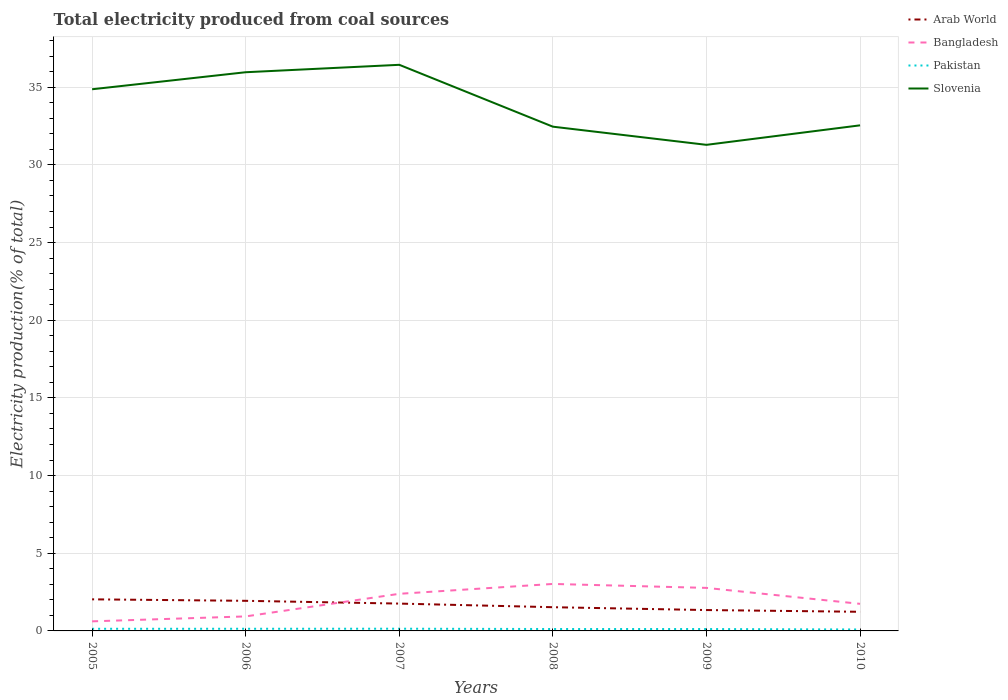How many different coloured lines are there?
Your response must be concise. 4. Across all years, what is the maximum total electricity produced in Slovenia?
Provide a short and direct response. 31.29. What is the total total electricity produced in Pakistan in the graph?
Provide a succinct answer. -0. What is the difference between the highest and the second highest total electricity produced in Pakistan?
Offer a very short reply. 0.05. Is the total electricity produced in Slovenia strictly greater than the total electricity produced in Arab World over the years?
Provide a short and direct response. No. How many years are there in the graph?
Your response must be concise. 6. What is the difference between two consecutive major ticks on the Y-axis?
Make the answer very short. 5. Does the graph contain any zero values?
Offer a terse response. No. Where does the legend appear in the graph?
Your answer should be very brief. Top right. How are the legend labels stacked?
Ensure brevity in your answer.  Vertical. What is the title of the graph?
Provide a succinct answer. Total electricity produced from coal sources. Does "India" appear as one of the legend labels in the graph?
Provide a short and direct response. No. What is the Electricity production(% of total) in Arab World in 2005?
Your answer should be very brief. 2.03. What is the Electricity production(% of total) in Bangladesh in 2005?
Your answer should be compact. 0.62. What is the Electricity production(% of total) in Pakistan in 2005?
Give a very brief answer. 0.14. What is the Electricity production(% of total) of Slovenia in 2005?
Keep it short and to the point. 34.87. What is the Electricity production(% of total) of Arab World in 2006?
Ensure brevity in your answer.  1.94. What is the Electricity production(% of total) of Bangladesh in 2006?
Offer a very short reply. 0.93. What is the Electricity production(% of total) of Pakistan in 2006?
Keep it short and to the point. 0.14. What is the Electricity production(% of total) of Slovenia in 2006?
Ensure brevity in your answer.  35.96. What is the Electricity production(% of total) in Arab World in 2007?
Your answer should be compact. 1.76. What is the Electricity production(% of total) in Bangladesh in 2007?
Offer a terse response. 2.39. What is the Electricity production(% of total) of Pakistan in 2007?
Your response must be concise. 0.14. What is the Electricity production(% of total) in Slovenia in 2007?
Keep it short and to the point. 36.44. What is the Electricity production(% of total) in Arab World in 2008?
Ensure brevity in your answer.  1.53. What is the Electricity production(% of total) in Bangladesh in 2008?
Give a very brief answer. 3.02. What is the Electricity production(% of total) in Pakistan in 2008?
Ensure brevity in your answer.  0.12. What is the Electricity production(% of total) of Slovenia in 2008?
Keep it short and to the point. 32.46. What is the Electricity production(% of total) of Arab World in 2009?
Your answer should be compact. 1.34. What is the Electricity production(% of total) in Bangladesh in 2009?
Provide a short and direct response. 2.77. What is the Electricity production(% of total) in Pakistan in 2009?
Offer a terse response. 0.12. What is the Electricity production(% of total) of Slovenia in 2009?
Provide a short and direct response. 31.29. What is the Electricity production(% of total) in Arab World in 2010?
Your answer should be very brief. 1.23. What is the Electricity production(% of total) of Bangladesh in 2010?
Keep it short and to the point. 1.74. What is the Electricity production(% of total) in Pakistan in 2010?
Give a very brief answer. 0.09. What is the Electricity production(% of total) of Slovenia in 2010?
Make the answer very short. 32.55. Across all years, what is the maximum Electricity production(% of total) in Arab World?
Your answer should be very brief. 2.03. Across all years, what is the maximum Electricity production(% of total) of Bangladesh?
Your answer should be very brief. 3.02. Across all years, what is the maximum Electricity production(% of total) of Pakistan?
Your answer should be very brief. 0.14. Across all years, what is the maximum Electricity production(% of total) in Slovenia?
Your answer should be compact. 36.44. Across all years, what is the minimum Electricity production(% of total) of Arab World?
Your answer should be compact. 1.23. Across all years, what is the minimum Electricity production(% of total) in Bangladesh?
Provide a short and direct response. 0.62. Across all years, what is the minimum Electricity production(% of total) in Pakistan?
Your answer should be very brief. 0.09. Across all years, what is the minimum Electricity production(% of total) in Slovenia?
Give a very brief answer. 31.29. What is the total Electricity production(% of total) of Arab World in the graph?
Your response must be concise. 9.83. What is the total Electricity production(% of total) of Bangladesh in the graph?
Keep it short and to the point. 11.48. What is the total Electricity production(% of total) in Pakistan in the graph?
Your answer should be very brief. 0.76. What is the total Electricity production(% of total) in Slovenia in the graph?
Offer a very short reply. 203.57. What is the difference between the Electricity production(% of total) of Arab World in 2005 and that in 2006?
Your response must be concise. 0.1. What is the difference between the Electricity production(% of total) in Bangladesh in 2005 and that in 2006?
Offer a terse response. -0.32. What is the difference between the Electricity production(% of total) in Pakistan in 2005 and that in 2006?
Your response must be concise. -0. What is the difference between the Electricity production(% of total) of Slovenia in 2005 and that in 2006?
Offer a terse response. -1.1. What is the difference between the Electricity production(% of total) in Arab World in 2005 and that in 2007?
Provide a short and direct response. 0.27. What is the difference between the Electricity production(% of total) in Bangladesh in 2005 and that in 2007?
Ensure brevity in your answer.  -1.77. What is the difference between the Electricity production(% of total) of Pakistan in 2005 and that in 2007?
Offer a terse response. -0. What is the difference between the Electricity production(% of total) of Slovenia in 2005 and that in 2007?
Keep it short and to the point. -1.57. What is the difference between the Electricity production(% of total) of Arab World in 2005 and that in 2008?
Offer a terse response. 0.51. What is the difference between the Electricity production(% of total) of Bangladesh in 2005 and that in 2008?
Provide a succinct answer. -2.41. What is the difference between the Electricity production(% of total) of Pakistan in 2005 and that in 2008?
Make the answer very short. 0.01. What is the difference between the Electricity production(% of total) in Slovenia in 2005 and that in 2008?
Your answer should be very brief. 2.41. What is the difference between the Electricity production(% of total) in Arab World in 2005 and that in 2009?
Offer a very short reply. 0.69. What is the difference between the Electricity production(% of total) in Bangladesh in 2005 and that in 2009?
Offer a very short reply. -2.15. What is the difference between the Electricity production(% of total) of Pakistan in 2005 and that in 2009?
Offer a terse response. 0.02. What is the difference between the Electricity production(% of total) in Slovenia in 2005 and that in 2009?
Your answer should be very brief. 3.58. What is the difference between the Electricity production(% of total) in Arab World in 2005 and that in 2010?
Give a very brief answer. 0.8. What is the difference between the Electricity production(% of total) of Bangladesh in 2005 and that in 2010?
Provide a short and direct response. -1.13. What is the difference between the Electricity production(% of total) in Pakistan in 2005 and that in 2010?
Ensure brevity in your answer.  0.04. What is the difference between the Electricity production(% of total) of Slovenia in 2005 and that in 2010?
Your answer should be compact. 2.32. What is the difference between the Electricity production(% of total) of Arab World in 2006 and that in 2007?
Provide a succinct answer. 0.18. What is the difference between the Electricity production(% of total) in Bangladesh in 2006 and that in 2007?
Keep it short and to the point. -1.46. What is the difference between the Electricity production(% of total) of Pakistan in 2006 and that in 2007?
Offer a terse response. -0. What is the difference between the Electricity production(% of total) of Slovenia in 2006 and that in 2007?
Offer a very short reply. -0.48. What is the difference between the Electricity production(% of total) in Arab World in 2006 and that in 2008?
Your response must be concise. 0.41. What is the difference between the Electricity production(% of total) in Bangladesh in 2006 and that in 2008?
Offer a very short reply. -2.09. What is the difference between the Electricity production(% of total) in Pakistan in 2006 and that in 2008?
Offer a terse response. 0.02. What is the difference between the Electricity production(% of total) in Slovenia in 2006 and that in 2008?
Your answer should be very brief. 3.5. What is the difference between the Electricity production(% of total) in Arab World in 2006 and that in 2009?
Give a very brief answer. 0.59. What is the difference between the Electricity production(% of total) in Bangladesh in 2006 and that in 2009?
Offer a very short reply. -1.84. What is the difference between the Electricity production(% of total) in Pakistan in 2006 and that in 2009?
Keep it short and to the point. 0.02. What is the difference between the Electricity production(% of total) in Slovenia in 2006 and that in 2009?
Keep it short and to the point. 4.67. What is the difference between the Electricity production(% of total) in Arab World in 2006 and that in 2010?
Offer a very short reply. 0.71. What is the difference between the Electricity production(% of total) of Bangladesh in 2006 and that in 2010?
Keep it short and to the point. -0.81. What is the difference between the Electricity production(% of total) in Pakistan in 2006 and that in 2010?
Provide a succinct answer. 0.05. What is the difference between the Electricity production(% of total) in Slovenia in 2006 and that in 2010?
Your response must be concise. 3.42. What is the difference between the Electricity production(% of total) of Arab World in 2007 and that in 2008?
Offer a very short reply. 0.23. What is the difference between the Electricity production(% of total) in Bangladesh in 2007 and that in 2008?
Offer a very short reply. -0.64. What is the difference between the Electricity production(% of total) in Pakistan in 2007 and that in 2008?
Ensure brevity in your answer.  0.02. What is the difference between the Electricity production(% of total) in Slovenia in 2007 and that in 2008?
Your response must be concise. 3.98. What is the difference between the Electricity production(% of total) in Arab World in 2007 and that in 2009?
Keep it short and to the point. 0.42. What is the difference between the Electricity production(% of total) of Bangladesh in 2007 and that in 2009?
Ensure brevity in your answer.  -0.38. What is the difference between the Electricity production(% of total) of Pakistan in 2007 and that in 2009?
Ensure brevity in your answer.  0.02. What is the difference between the Electricity production(% of total) in Slovenia in 2007 and that in 2009?
Your answer should be compact. 5.15. What is the difference between the Electricity production(% of total) in Arab World in 2007 and that in 2010?
Your response must be concise. 0.53. What is the difference between the Electricity production(% of total) in Bangladesh in 2007 and that in 2010?
Your response must be concise. 0.65. What is the difference between the Electricity production(% of total) of Pakistan in 2007 and that in 2010?
Make the answer very short. 0.05. What is the difference between the Electricity production(% of total) in Slovenia in 2007 and that in 2010?
Offer a terse response. 3.9. What is the difference between the Electricity production(% of total) in Arab World in 2008 and that in 2009?
Offer a very short reply. 0.18. What is the difference between the Electricity production(% of total) of Bangladesh in 2008 and that in 2009?
Give a very brief answer. 0.25. What is the difference between the Electricity production(% of total) in Pakistan in 2008 and that in 2009?
Provide a succinct answer. 0. What is the difference between the Electricity production(% of total) of Slovenia in 2008 and that in 2009?
Ensure brevity in your answer.  1.17. What is the difference between the Electricity production(% of total) in Arab World in 2008 and that in 2010?
Provide a succinct answer. 0.3. What is the difference between the Electricity production(% of total) of Bangladesh in 2008 and that in 2010?
Your answer should be compact. 1.28. What is the difference between the Electricity production(% of total) of Pakistan in 2008 and that in 2010?
Provide a short and direct response. 0.03. What is the difference between the Electricity production(% of total) of Slovenia in 2008 and that in 2010?
Ensure brevity in your answer.  -0.09. What is the difference between the Electricity production(% of total) in Arab World in 2009 and that in 2010?
Provide a succinct answer. 0.11. What is the difference between the Electricity production(% of total) of Bangladesh in 2009 and that in 2010?
Provide a succinct answer. 1.03. What is the difference between the Electricity production(% of total) in Pakistan in 2009 and that in 2010?
Provide a short and direct response. 0.03. What is the difference between the Electricity production(% of total) in Slovenia in 2009 and that in 2010?
Ensure brevity in your answer.  -1.25. What is the difference between the Electricity production(% of total) of Arab World in 2005 and the Electricity production(% of total) of Bangladesh in 2006?
Your answer should be very brief. 1.1. What is the difference between the Electricity production(% of total) in Arab World in 2005 and the Electricity production(% of total) in Pakistan in 2006?
Offer a very short reply. 1.9. What is the difference between the Electricity production(% of total) of Arab World in 2005 and the Electricity production(% of total) of Slovenia in 2006?
Your response must be concise. -33.93. What is the difference between the Electricity production(% of total) in Bangladesh in 2005 and the Electricity production(% of total) in Pakistan in 2006?
Your response must be concise. 0.48. What is the difference between the Electricity production(% of total) in Bangladesh in 2005 and the Electricity production(% of total) in Slovenia in 2006?
Provide a succinct answer. -35.35. What is the difference between the Electricity production(% of total) of Pakistan in 2005 and the Electricity production(% of total) of Slovenia in 2006?
Your answer should be very brief. -35.83. What is the difference between the Electricity production(% of total) of Arab World in 2005 and the Electricity production(% of total) of Bangladesh in 2007?
Keep it short and to the point. -0.36. What is the difference between the Electricity production(% of total) of Arab World in 2005 and the Electricity production(% of total) of Pakistan in 2007?
Offer a terse response. 1.89. What is the difference between the Electricity production(% of total) of Arab World in 2005 and the Electricity production(% of total) of Slovenia in 2007?
Provide a short and direct response. -34.41. What is the difference between the Electricity production(% of total) of Bangladesh in 2005 and the Electricity production(% of total) of Pakistan in 2007?
Your response must be concise. 0.47. What is the difference between the Electricity production(% of total) of Bangladesh in 2005 and the Electricity production(% of total) of Slovenia in 2007?
Keep it short and to the point. -35.83. What is the difference between the Electricity production(% of total) of Pakistan in 2005 and the Electricity production(% of total) of Slovenia in 2007?
Your response must be concise. -36.3. What is the difference between the Electricity production(% of total) of Arab World in 2005 and the Electricity production(% of total) of Bangladesh in 2008?
Make the answer very short. -0.99. What is the difference between the Electricity production(% of total) in Arab World in 2005 and the Electricity production(% of total) in Pakistan in 2008?
Give a very brief answer. 1.91. What is the difference between the Electricity production(% of total) in Arab World in 2005 and the Electricity production(% of total) in Slovenia in 2008?
Your answer should be very brief. -30.43. What is the difference between the Electricity production(% of total) in Bangladesh in 2005 and the Electricity production(% of total) in Pakistan in 2008?
Offer a very short reply. 0.49. What is the difference between the Electricity production(% of total) of Bangladesh in 2005 and the Electricity production(% of total) of Slovenia in 2008?
Provide a succinct answer. -31.84. What is the difference between the Electricity production(% of total) of Pakistan in 2005 and the Electricity production(% of total) of Slovenia in 2008?
Provide a succinct answer. -32.32. What is the difference between the Electricity production(% of total) in Arab World in 2005 and the Electricity production(% of total) in Bangladesh in 2009?
Your response must be concise. -0.74. What is the difference between the Electricity production(% of total) in Arab World in 2005 and the Electricity production(% of total) in Pakistan in 2009?
Your answer should be very brief. 1.91. What is the difference between the Electricity production(% of total) of Arab World in 2005 and the Electricity production(% of total) of Slovenia in 2009?
Ensure brevity in your answer.  -29.26. What is the difference between the Electricity production(% of total) in Bangladesh in 2005 and the Electricity production(% of total) in Pakistan in 2009?
Give a very brief answer. 0.49. What is the difference between the Electricity production(% of total) of Bangladesh in 2005 and the Electricity production(% of total) of Slovenia in 2009?
Provide a succinct answer. -30.67. What is the difference between the Electricity production(% of total) in Pakistan in 2005 and the Electricity production(% of total) in Slovenia in 2009?
Provide a short and direct response. -31.15. What is the difference between the Electricity production(% of total) in Arab World in 2005 and the Electricity production(% of total) in Bangladesh in 2010?
Offer a very short reply. 0.29. What is the difference between the Electricity production(% of total) of Arab World in 2005 and the Electricity production(% of total) of Pakistan in 2010?
Make the answer very short. 1.94. What is the difference between the Electricity production(% of total) of Arab World in 2005 and the Electricity production(% of total) of Slovenia in 2010?
Give a very brief answer. -30.51. What is the difference between the Electricity production(% of total) of Bangladesh in 2005 and the Electricity production(% of total) of Pakistan in 2010?
Your response must be concise. 0.52. What is the difference between the Electricity production(% of total) in Bangladesh in 2005 and the Electricity production(% of total) in Slovenia in 2010?
Provide a short and direct response. -31.93. What is the difference between the Electricity production(% of total) of Pakistan in 2005 and the Electricity production(% of total) of Slovenia in 2010?
Provide a short and direct response. -32.41. What is the difference between the Electricity production(% of total) in Arab World in 2006 and the Electricity production(% of total) in Bangladesh in 2007?
Make the answer very short. -0.45. What is the difference between the Electricity production(% of total) of Arab World in 2006 and the Electricity production(% of total) of Pakistan in 2007?
Ensure brevity in your answer.  1.8. What is the difference between the Electricity production(% of total) of Arab World in 2006 and the Electricity production(% of total) of Slovenia in 2007?
Provide a short and direct response. -34.5. What is the difference between the Electricity production(% of total) in Bangladesh in 2006 and the Electricity production(% of total) in Pakistan in 2007?
Ensure brevity in your answer.  0.79. What is the difference between the Electricity production(% of total) in Bangladesh in 2006 and the Electricity production(% of total) in Slovenia in 2007?
Make the answer very short. -35.51. What is the difference between the Electricity production(% of total) of Pakistan in 2006 and the Electricity production(% of total) of Slovenia in 2007?
Ensure brevity in your answer.  -36.3. What is the difference between the Electricity production(% of total) of Arab World in 2006 and the Electricity production(% of total) of Bangladesh in 2008?
Give a very brief answer. -1.09. What is the difference between the Electricity production(% of total) of Arab World in 2006 and the Electricity production(% of total) of Pakistan in 2008?
Provide a short and direct response. 1.81. What is the difference between the Electricity production(% of total) in Arab World in 2006 and the Electricity production(% of total) in Slovenia in 2008?
Offer a very short reply. -30.52. What is the difference between the Electricity production(% of total) of Bangladesh in 2006 and the Electricity production(% of total) of Pakistan in 2008?
Keep it short and to the point. 0.81. What is the difference between the Electricity production(% of total) of Bangladesh in 2006 and the Electricity production(% of total) of Slovenia in 2008?
Give a very brief answer. -31.52. What is the difference between the Electricity production(% of total) of Pakistan in 2006 and the Electricity production(% of total) of Slovenia in 2008?
Provide a short and direct response. -32.32. What is the difference between the Electricity production(% of total) of Arab World in 2006 and the Electricity production(% of total) of Bangladesh in 2009?
Make the answer very short. -0.83. What is the difference between the Electricity production(% of total) of Arab World in 2006 and the Electricity production(% of total) of Pakistan in 2009?
Provide a short and direct response. 1.82. What is the difference between the Electricity production(% of total) of Arab World in 2006 and the Electricity production(% of total) of Slovenia in 2009?
Give a very brief answer. -29.35. What is the difference between the Electricity production(% of total) of Bangladesh in 2006 and the Electricity production(% of total) of Pakistan in 2009?
Keep it short and to the point. 0.81. What is the difference between the Electricity production(% of total) of Bangladesh in 2006 and the Electricity production(% of total) of Slovenia in 2009?
Provide a succinct answer. -30.36. What is the difference between the Electricity production(% of total) of Pakistan in 2006 and the Electricity production(% of total) of Slovenia in 2009?
Provide a short and direct response. -31.15. What is the difference between the Electricity production(% of total) of Arab World in 2006 and the Electricity production(% of total) of Bangladesh in 2010?
Ensure brevity in your answer.  0.19. What is the difference between the Electricity production(% of total) of Arab World in 2006 and the Electricity production(% of total) of Pakistan in 2010?
Offer a terse response. 1.84. What is the difference between the Electricity production(% of total) in Arab World in 2006 and the Electricity production(% of total) in Slovenia in 2010?
Ensure brevity in your answer.  -30.61. What is the difference between the Electricity production(% of total) of Bangladesh in 2006 and the Electricity production(% of total) of Pakistan in 2010?
Your answer should be compact. 0.84. What is the difference between the Electricity production(% of total) in Bangladesh in 2006 and the Electricity production(% of total) in Slovenia in 2010?
Provide a short and direct response. -31.61. What is the difference between the Electricity production(% of total) of Pakistan in 2006 and the Electricity production(% of total) of Slovenia in 2010?
Ensure brevity in your answer.  -32.41. What is the difference between the Electricity production(% of total) in Arab World in 2007 and the Electricity production(% of total) in Bangladesh in 2008?
Offer a very short reply. -1.26. What is the difference between the Electricity production(% of total) of Arab World in 2007 and the Electricity production(% of total) of Pakistan in 2008?
Give a very brief answer. 1.64. What is the difference between the Electricity production(% of total) of Arab World in 2007 and the Electricity production(% of total) of Slovenia in 2008?
Your answer should be very brief. -30.7. What is the difference between the Electricity production(% of total) in Bangladesh in 2007 and the Electricity production(% of total) in Pakistan in 2008?
Ensure brevity in your answer.  2.27. What is the difference between the Electricity production(% of total) in Bangladesh in 2007 and the Electricity production(% of total) in Slovenia in 2008?
Keep it short and to the point. -30.07. What is the difference between the Electricity production(% of total) of Pakistan in 2007 and the Electricity production(% of total) of Slovenia in 2008?
Give a very brief answer. -32.32. What is the difference between the Electricity production(% of total) of Arab World in 2007 and the Electricity production(% of total) of Bangladesh in 2009?
Offer a terse response. -1.01. What is the difference between the Electricity production(% of total) of Arab World in 2007 and the Electricity production(% of total) of Pakistan in 2009?
Offer a terse response. 1.64. What is the difference between the Electricity production(% of total) in Arab World in 2007 and the Electricity production(% of total) in Slovenia in 2009?
Give a very brief answer. -29.53. What is the difference between the Electricity production(% of total) of Bangladesh in 2007 and the Electricity production(% of total) of Pakistan in 2009?
Keep it short and to the point. 2.27. What is the difference between the Electricity production(% of total) of Bangladesh in 2007 and the Electricity production(% of total) of Slovenia in 2009?
Make the answer very short. -28.9. What is the difference between the Electricity production(% of total) in Pakistan in 2007 and the Electricity production(% of total) in Slovenia in 2009?
Offer a very short reply. -31.15. What is the difference between the Electricity production(% of total) in Arab World in 2007 and the Electricity production(% of total) in Bangladesh in 2010?
Provide a short and direct response. 0.02. What is the difference between the Electricity production(% of total) in Arab World in 2007 and the Electricity production(% of total) in Pakistan in 2010?
Your answer should be very brief. 1.67. What is the difference between the Electricity production(% of total) of Arab World in 2007 and the Electricity production(% of total) of Slovenia in 2010?
Keep it short and to the point. -30.79. What is the difference between the Electricity production(% of total) of Bangladesh in 2007 and the Electricity production(% of total) of Pakistan in 2010?
Provide a succinct answer. 2.3. What is the difference between the Electricity production(% of total) of Bangladesh in 2007 and the Electricity production(% of total) of Slovenia in 2010?
Give a very brief answer. -30.16. What is the difference between the Electricity production(% of total) in Pakistan in 2007 and the Electricity production(% of total) in Slovenia in 2010?
Provide a succinct answer. -32.4. What is the difference between the Electricity production(% of total) of Arab World in 2008 and the Electricity production(% of total) of Bangladesh in 2009?
Your response must be concise. -1.24. What is the difference between the Electricity production(% of total) in Arab World in 2008 and the Electricity production(% of total) in Pakistan in 2009?
Give a very brief answer. 1.41. What is the difference between the Electricity production(% of total) of Arab World in 2008 and the Electricity production(% of total) of Slovenia in 2009?
Your answer should be very brief. -29.76. What is the difference between the Electricity production(% of total) of Bangladesh in 2008 and the Electricity production(% of total) of Pakistan in 2009?
Give a very brief answer. 2.9. What is the difference between the Electricity production(% of total) of Bangladesh in 2008 and the Electricity production(% of total) of Slovenia in 2009?
Provide a short and direct response. -28.27. What is the difference between the Electricity production(% of total) in Pakistan in 2008 and the Electricity production(% of total) in Slovenia in 2009?
Provide a short and direct response. -31.17. What is the difference between the Electricity production(% of total) of Arab World in 2008 and the Electricity production(% of total) of Bangladesh in 2010?
Your answer should be very brief. -0.22. What is the difference between the Electricity production(% of total) in Arab World in 2008 and the Electricity production(% of total) in Pakistan in 2010?
Provide a succinct answer. 1.43. What is the difference between the Electricity production(% of total) of Arab World in 2008 and the Electricity production(% of total) of Slovenia in 2010?
Provide a succinct answer. -31.02. What is the difference between the Electricity production(% of total) in Bangladesh in 2008 and the Electricity production(% of total) in Pakistan in 2010?
Ensure brevity in your answer.  2.93. What is the difference between the Electricity production(% of total) of Bangladesh in 2008 and the Electricity production(% of total) of Slovenia in 2010?
Ensure brevity in your answer.  -29.52. What is the difference between the Electricity production(% of total) in Pakistan in 2008 and the Electricity production(% of total) in Slovenia in 2010?
Offer a terse response. -32.42. What is the difference between the Electricity production(% of total) of Arab World in 2009 and the Electricity production(% of total) of Bangladesh in 2010?
Your answer should be very brief. -0.4. What is the difference between the Electricity production(% of total) of Arab World in 2009 and the Electricity production(% of total) of Pakistan in 2010?
Give a very brief answer. 1.25. What is the difference between the Electricity production(% of total) in Arab World in 2009 and the Electricity production(% of total) in Slovenia in 2010?
Make the answer very short. -31.2. What is the difference between the Electricity production(% of total) in Bangladesh in 2009 and the Electricity production(% of total) in Pakistan in 2010?
Make the answer very short. 2.68. What is the difference between the Electricity production(% of total) of Bangladesh in 2009 and the Electricity production(% of total) of Slovenia in 2010?
Give a very brief answer. -29.78. What is the difference between the Electricity production(% of total) in Pakistan in 2009 and the Electricity production(% of total) in Slovenia in 2010?
Your answer should be compact. -32.42. What is the average Electricity production(% of total) of Arab World per year?
Your answer should be very brief. 1.64. What is the average Electricity production(% of total) in Bangladesh per year?
Give a very brief answer. 1.91. What is the average Electricity production(% of total) in Pakistan per year?
Offer a very short reply. 0.13. What is the average Electricity production(% of total) in Slovenia per year?
Your answer should be compact. 33.93. In the year 2005, what is the difference between the Electricity production(% of total) of Arab World and Electricity production(% of total) of Bangladesh?
Offer a terse response. 1.42. In the year 2005, what is the difference between the Electricity production(% of total) in Arab World and Electricity production(% of total) in Pakistan?
Keep it short and to the point. 1.9. In the year 2005, what is the difference between the Electricity production(% of total) in Arab World and Electricity production(% of total) in Slovenia?
Your answer should be very brief. -32.83. In the year 2005, what is the difference between the Electricity production(% of total) of Bangladesh and Electricity production(% of total) of Pakistan?
Offer a terse response. 0.48. In the year 2005, what is the difference between the Electricity production(% of total) in Bangladesh and Electricity production(% of total) in Slovenia?
Make the answer very short. -34.25. In the year 2005, what is the difference between the Electricity production(% of total) in Pakistan and Electricity production(% of total) in Slovenia?
Ensure brevity in your answer.  -34.73. In the year 2006, what is the difference between the Electricity production(% of total) in Arab World and Electricity production(% of total) in Bangladesh?
Your response must be concise. 1. In the year 2006, what is the difference between the Electricity production(% of total) in Arab World and Electricity production(% of total) in Pakistan?
Make the answer very short. 1.8. In the year 2006, what is the difference between the Electricity production(% of total) of Arab World and Electricity production(% of total) of Slovenia?
Offer a very short reply. -34.03. In the year 2006, what is the difference between the Electricity production(% of total) in Bangladesh and Electricity production(% of total) in Pakistan?
Make the answer very short. 0.8. In the year 2006, what is the difference between the Electricity production(% of total) in Bangladesh and Electricity production(% of total) in Slovenia?
Provide a short and direct response. -35.03. In the year 2006, what is the difference between the Electricity production(% of total) in Pakistan and Electricity production(% of total) in Slovenia?
Your answer should be compact. -35.83. In the year 2007, what is the difference between the Electricity production(% of total) in Arab World and Electricity production(% of total) in Bangladesh?
Ensure brevity in your answer.  -0.63. In the year 2007, what is the difference between the Electricity production(% of total) of Arab World and Electricity production(% of total) of Pakistan?
Your answer should be compact. 1.62. In the year 2007, what is the difference between the Electricity production(% of total) in Arab World and Electricity production(% of total) in Slovenia?
Offer a very short reply. -34.68. In the year 2007, what is the difference between the Electricity production(% of total) of Bangladesh and Electricity production(% of total) of Pakistan?
Keep it short and to the point. 2.25. In the year 2007, what is the difference between the Electricity production(% of total) of Bangladesh and Electricity production(% of total) of Slovenia?
Give a very brief answer. -34.05. In the year 2007, what is the difference between the Electricity production(% of total) in Pakistan and Electricity production(% of total) in Slovenia?
Provide a short and direct response. -36.3. In the year 2008, what is the difference between the Electricity production(% of total) in Arab World and Electricity production(% of total) in Bangladesh?
Ensure brevity in your answer.  -1.5. In the year 2008, what is the difference between the Electricity production(% of total) in Arab World and Electricity production(% of total) in Pakistan?
Offer a very short reply. 1.4. In the year 2008, what is the difference between the Electricity production(% of total) of Arab World and Electricity production(% of total) of Slovenia?
Your answer should be very brief. -30.93. In the year 2008, what is the difference between the Electricity production(% of total) of Bangladesh and Electricity production(% of total) of Pakistan?
Give a very brief answer. 2.9. In the year 2008, what is the difference between the Electricity production(% of total) in Bangladesh and Electricity production(% of total) in Slovenia?
Keep it short and to the point. -29.43. In the year 2008, what is the difference between the Electricity production(% of total) of Pakistan and Electricity production(% of total) of Slovenia?
Ensure brevity in your answer.  -32.34. In the year 2009, what is the difference between the Electricity production(% of total) in Arab World and Electricity production(% of total) in Bangladesh?
Provide a short and direct response. -1.43. In the year 2009, what is the difference between the Electricity production(% of total) of Arab World and Electricity production(% of total) of Pakistan?
Offer a terse response. 1.22. In the year 2009, what is the difference between the Electricity production(% of total) in Arab World and Electricity production(% of total) in Slovenia?
Your answer should be very brief. -29.95. In the year 2009, what is the difference between the Electricity production(% of total) in Bangladesh and Electricity production(% of total) in Pakistan?
Give a very brief answer. 2.65. In the year 2009, what is the difference between the Electricity production(% of total) in Bangladesh and Electricity production(% of total) in Slovenia?
Provide a short and direct response. -28.52. In the year 2009, what is the difference between the Electricity production(% of total) in Pakistan and Electricity production(% of total) in Slovenia?
Keep it short and to the point. -31.17. In the year 2010, what is the difference between the Electricity production(% of total) of Arab World and Electricity production(% of total) of Bangladesh?
Your answer should be compact. -0.51. In the year 2010, what is the difference between the Electricity production(% of total) in Arab World and Electricity production(% of total) in Pakistan?
Your answer should be compact. 1.14. In the year 2010, what is the difference between the Electricity production(% of total) of Arab World and Electricity production(% of total) of Slovenia?
Keep it short and to the point. -31.31. In the year 2010, what is the difference between the Electricity production(% of total) in Bangladesh and Electricity production(% of total) in Pakistan?
Provide a short and direct response. 1.65. In the year 2010, what is the difference between the Electricity production(% of total) of Bangladesh and Electricity production(% of total) of Slovenia?
Your response must be concise. -30.8. In the year 2010, what is the difference between the Electricity production(% of total) of Pakistan and Electricity production(% of total) of Slovenia?
Provide a short and direct response. -32.45. What is the ratio of the Electricity production(% of total) of Arab World in 2005 to that in 2006?
Keep it short and to the point. 1.05. What is the ratio of the Electricity production(% of total) of Bangladesh in 2005 to that in 2006?
Your response must be concise. 0.66. What is the ratio of the Electricity production(% of total) in Pakistan in 2005 to that in 2006?
Your response must be concise. 0.99. What is the ratio of the Electricity production(% of total) of Slovenia in 2005 to that in 2006?
Keep it short and to the point. 0.97. What is the ratio of the Electricity production(% of total) of Arab World in 2005 to that in 2007?
Your answer should be compact. 1.16. What is the ratio of the Electricity production(% of total) in Bangladesh in 2005 to that in 2007?
Your answer should be very brief. 0.26. What is the ratio of the Electricity production(% of total) in Pakistan in 2005 to that in 2007?
Give a very brief answer. 0.97. What is the ratio of the Electricity production(% of total) of Slovenia in 2005 to that in 2007?
Make the answer very short. 0.96. What is the ratio of the Electricity production(% of total) of Arab World in 2005 to that in 2008?
Your response must be concise. 1.33. What is the ratio of the Electricity production(% of total) in Bangladesh in 2005 to that in 2008?
Give a very brief answer. 0.2. What is the ratio of the Electricity production(% of total) in Pakistan in 2005 to that in 2008?
Provide a short and direct response. 1.12. What is the ratio of the Electricity production(% of total) of Slovenia in 2005 to that in 2008?
Your response must be concise. 1.07. What is the ratio of the Electricity production(% of total) of Arab World in 2005 to that in 2009?
Make the answer very short. 1.51. What is the ratio of the Electricity production(% of total) in Bangladesh in 2005 to that in 2009?
Provide a succinct answer. 0.22. What is the ratio of the Electricity production(% of total) of Pakistan in 2005 to that in 2009?
Offer a very short reply. 1.13. What is the ratio of the Electricity production(% of total) of Slovenia in 2005 to that in 2009?
Your answer should be compact. 1.11. What is the ratio of the Electricity production(% of total) of Arab World in 2005 to that in 2010?
Keep it short and to the point. 1.65. What is the ratio of the Electricity production(% of total) of Bangladesh in 2005 to that in 2010?
Give a very brief answer. 0.35. What is the ratio of the Electricity production(% of total) of Pakistan in 2005 to that in 2010?
Offer a terse response. 1.48. What is the ratio of the Electricity production(% of total) in Slovenia in 2005 to that in 2010?
Your answer should be compact. 1.07. What is the ratio of the Electricity production(% of total) in Arab World in 2006 to that in 2007?
Give a very brief answer. 1.1. What is the ratio of the Electricity production(% of total) of Bangladesh in 2006 to that in 2007?
Offer a very short reply. 0.39. What is the ratio of the Electricity production(% of total) in Pakistan in 2006 to that in 2007?
Provide a succinct answer. 0.97. What is the ratio of the Electricity production(% of total) of Slovenia in 2006 to that in 2007?
Keep it short and to the point. 0.99. What is the ratio of the Electricity production(% of total) in Arab World in 2006 to that in 2008?
Offer a very short reply. 1.27. What is the ratio of the Electricity production(% of total) of Bangladesh in 2006 to that in 2008?
Provide a succinct answer. 0.31. What is the ratio of the Electricity production(% of total) in Pakistan in 2006 to that in 2008?
Provide a succinct answer. 1.12. What is the ratio of the Electricity production(% of total) of Slovenia in 2006 to that in 2008?
Ensure brevity in your answer.  1.11. What is the ratio of the Electricity production(% of total) of Arab World in 2006 to that in 2009?
Keep it short and to the point. 1.44. What is the ratio of the Electricity production(% of total) in Bangladesh in 2006 to that in 2009?
Your answer should be very brief. 0.34. What is the ratio of the Electricity production(% of total) of Pakistan in 2006 to that in 2009?
Your response must be concise. 1.14. What is the ratio of the Electricity production(% of total) in Slovenia in 2006 to that in 2009?
Provide a short and direct response. 1.15. What is the ratio of the Electricity production(% of total) of Arab World in 2006 to that in 2010?
Give a very brief answer. 1.57. What is the ratio of the Electricity production(% of total) of Bangladesh in 2006 to that in 2010?
Offer a very short reply. 0.54. What is the ratio of the Electricity production(% of total) of Pakistan in 2006 to that in 2010?
Provide a short and direct response. 1.49. What is the ratio of the Electricity production(% of total) of Slovenia in 2006 to that in 2010?
Keep it short and to the point. 1.1. What is the ratio of the Electricity production(% of total) of Arab World in 2007 to that in 2008?
Offer a terse response. 1.15. What is the ratio of the Electricity production(% of total) of Bangladesh in 2007 to that in 2008?
Keep it short and to the point. 0.79. What is the ratio of the Electricity production(% of total) in Pakistan in 2007 to that in 2008?
Your answer should be very brief. 1.15. What is the ratio of the Electricity production(% of total) in Slovenia in 2007 to that in 2008?
Your response must be concise. 1.12. What is the ratio of the Electricity production(% of total) of Arab World in 2007 to that in 2009?
Make the answer very short. 1.31. What is the ratio of the Electricity production(% of total) in Bangladesh in 2007 to that in 2009?
Your answer should be very brief. 0.86. What is the ratio of the Electricity production(% of total) of Pakistan in 2007 to that in 2009?
Your response must be concise. 1.17. What is the ratio of the Electricity production(% of total) in Slovenia in 2007 to that in 2009?
Provide a succinct answer. 1.16. What is the ratio of the Electricity production(% of total) of Arab World in 2007 to that in 2010?
Ensure brevity in your answer.  1.43. What is the ratio of the Electricity production(% of total) of Bangladesh in 2007 to that in 2010?
Your response must be concise. 1.37. What is the ratio of the Electricity production(% of total) in Pakistan in 2007 to that in 2010?
Provide a short and direct response. 1.52. What is the ratio of the Electricity production(% of total) in Slovenia in 2007 to that in 2010?
Provide a succinct answer. 1.12. What is the ratio of the Electricity production(% of total) of Arab World in 2008 to that in 2009?
Provide a succinct answer. 1.14. What is the ratio of the Electricity production(% of total) of Bangladesh in 2008 to that in 2009?
Provide a succinct answer. 1.09. What is the ratio of the Electricity production(% of total) of Pakistan in 2008 to that in 2009?
Make the answer very short. 1.01. What is the ratio of the Electricity production(% of total) in Slovenia in 2008 to that in 2009?
Your response must be concise. 1.04. What is the ratio of the Electricity production(% of total) of Arab World in 2008 to that in 2010?
Make the answer very short. 1.24. What is the ratio of the Electricity production(% of total) in Bangladesh in 2008 to that in 2010?
Make the answer very short. 1.73. What is the ratio of the Electricity production(% of total) of Pakistan in 2008 to that in 2010?
Ensure brevity in your answer.  1.32. What is the ratio of the Electricity production(% of total) of Slovenia in 2008 to that in 2010?
Offer a very short reply. 1. What is the ratio of the Electricity production(% of total) in Bangladesh in 2009 to that in 2010?
Ensure brevity in your answer.  1.59. What is the ratio of the Electricity production(% of total) of Pakistan in 2009 to that in 2010?
Your response must be concise. 1.3. What is the ratio of the Electricity production(% of total) of Slovenia in 2009 to that in 2010?
Offer a very short reply. 0.96. What is the difference between the highest and the second highest Electricity production(% of total) of Arab World?
Offer a terse response. 0.1. What is the difference between the highest and the second highest Electricity production(% of total) in Bangladesh?
Ensure brevity in your answer.  0.25. What is the difference between the highest and the second highest Electricity production(% of total) in Pakistan?
Your response must be concise. 0. What is the difference between the highest and the second highest Electricity production(% of total) of Slovenia?
Offer a very short reply. 0.48. What is the difference between the highest and the lowest Electricity production(% of total) of Arab World?
Your answer should be compact. 0.8. What is the difference between the highest and the lowest Electricity production(% of total) in Bangladesh?
Give a very brief answer. 2.41. What is the difference between the highest and the lowest Electricity production(% of total) in Pakistan?
Your answer should be compact. 0.05. What is the difference between the highest and the lowest Electricity production(% of total) in Slovenia?
Provide a short and direct response. 5.15. 